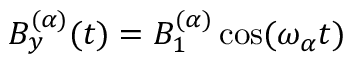<formula> <loc_0><loc_0><loc_500><loc_500>B _ { y } ^ { ( \alpha ) } ( t ) = B _ { 1 } ^ { ( \alpha ) } \cos ( \omega _ { \alpha } t )</formula> 